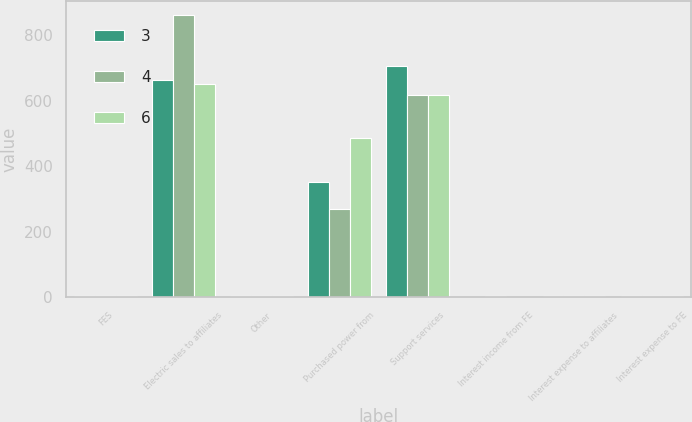Convert chart. <chart><loc_0><loc_0><loc_500><loc_500><stacked_bar_chart><ecel><fcel>FES<fcel>Electric sales to affiliates<fcel>Other<fcel>Purchased power from<fcel>Support services<fcel>Interest income from FE<fcel>Interest expense to affiliates<fcel>Interest expense to FE<nl><fcel>3<fcel>6<fcel>664<fcel>6<fcel>353<fcel>705<fcel>2<fcel>4<fcel>3<nl><fcel>4<fcel>6<fcel>861<fcel>6<fcel>271<fcel>619<fcel>3<fcel>3<fcel>4<nl><fcel>6<fcel>6<fcel>652<fcel>6<fcel>486<fcel>619<fcel>2<fcel>4<fcel>6<nl></chart> 